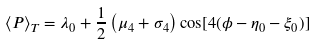Convert formula to latex. <formula><loc_0><loc_0><loc_500><loc_500>\langle P \rangle _ { T } = \lambda _ { 0 } + \frac { 1 } { 2 } \left ( \mu _ { 4 } + \sigma _ { 4 } \right ) \cos [ 4 ( \phi - \eta _ { 0 } - \xi _ { 0 } ) ]</formula> 